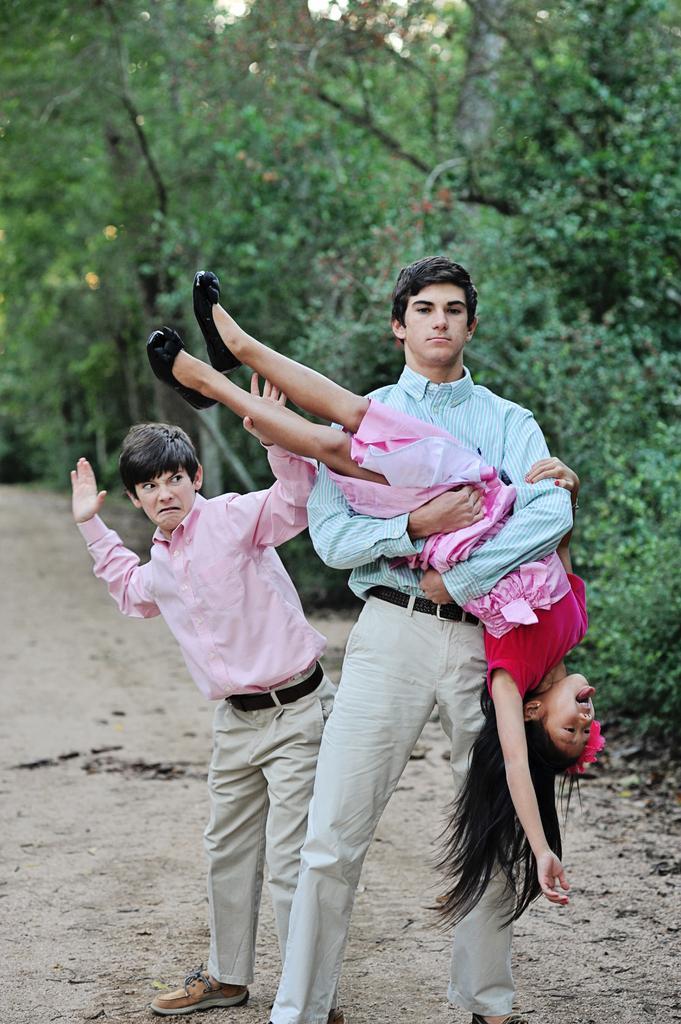Can you describe this image briefly? In this picture we can see there are two persons standing on the ground and a man is holding a girl. Behind the three persons, there are trees. 